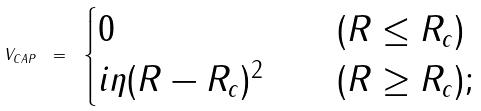<formula> <loc_0><loc_0><loc_500><loc_500>V _ { C A P } \ = \ \begin{cases} 0 & \quad ( R \leq R _ { c } ) \\ i \eta ( R - R _ { c } ) ^ { 2 } & \quad ( R \geq R _ { c } ) ; \end{cases}</formula> 